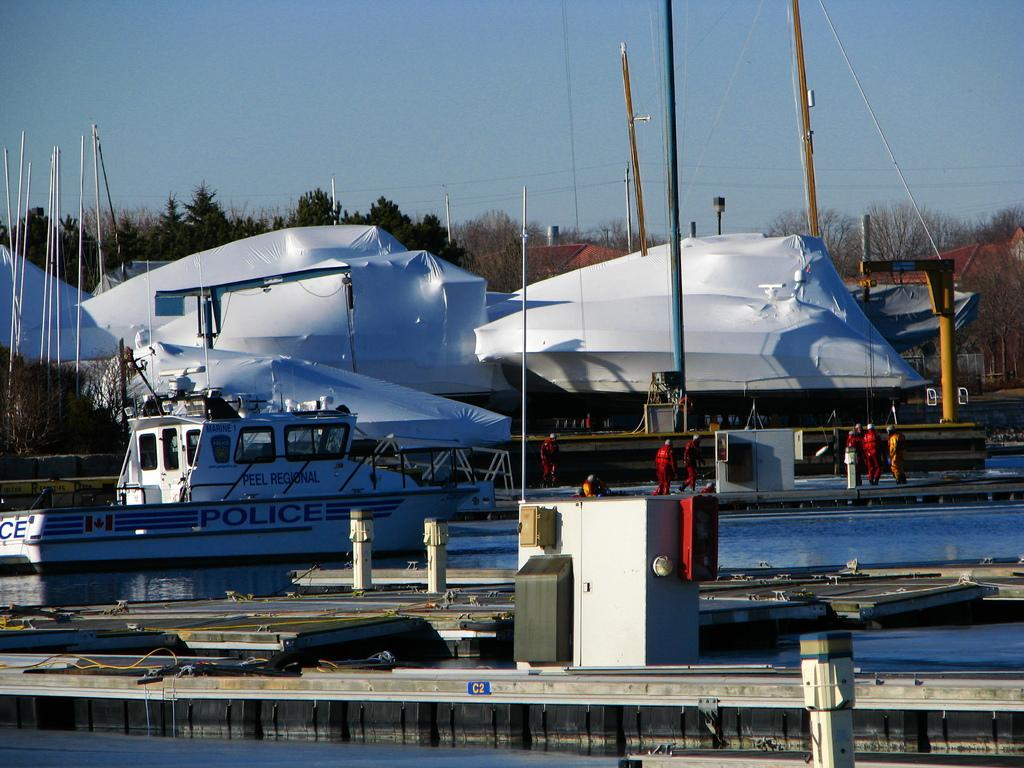Provide a one-sentence caption for the provided image. a boat that has the word police on the side. 